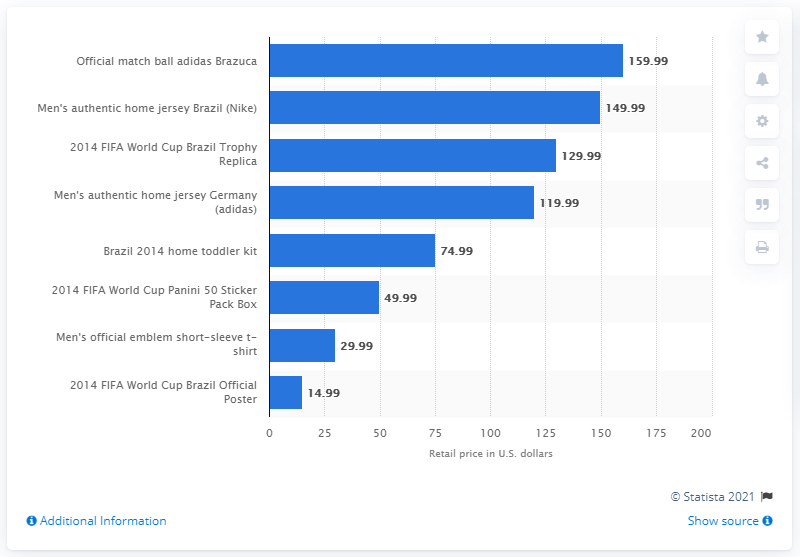Identify some key points in this picture. The Brazuca game ball retails for $159.99. 